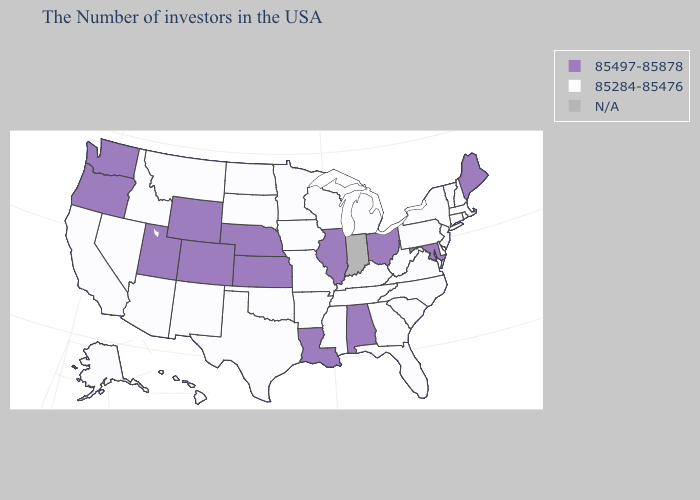What is the value of Vermont?
Keep it brief. 85284-85476. Does the map have missing data?
Concise answer only. Yes. Name the states that have a value in the range 85497-85878?
Be succinct. Maine, Maryland, Ohio, Alabama, Illinois, Louisiana, Kansas, Nebraska, Wyoming, Colorado, Utah, Washington, Oregon. Does the map have missing data?
Write a very short answer. Yes. What is the lowest value in the USA?
Give a very brief answer. 85284-85476. Name the states that have a value in the range 85497-85878?
Be succinct. Maine, Maryland, Ohio, Alabama, Illinois, Louisiana, Kansas, Nebraska, Wyoming, Colorado, Utah, Washington, Oregon. What is the value of Arizona?
Concise answer only. 85284-85476. Name the states that have a value in the range 85497-85878?
Keep it brief. Maine, Maryland, Ohio, Alabama, Illinois, Louisiana, Kansas, Nebraska, Wyoming, Colorado, Utah, Washington, Oregon. What is the highest value in states that border Kentucky?
Write a very short answer. 85497-85878. What is the value of New Hampshire?
Answer briefly. 85284-85476. Does Louisiana have the highest value in the South?
Concise answer only. Yes. What is the highest value in the USA?
Keep it brief. 85497-85878. Does the first symbol in the legend represent the smallest category?
Concise answer only. No. Does the map have missing data?
Write a very short answer. Yes. Which states hav the highest value in the West?
Answer briefly. Wyoming, Colorado, Utah, Washington, Oregon. 